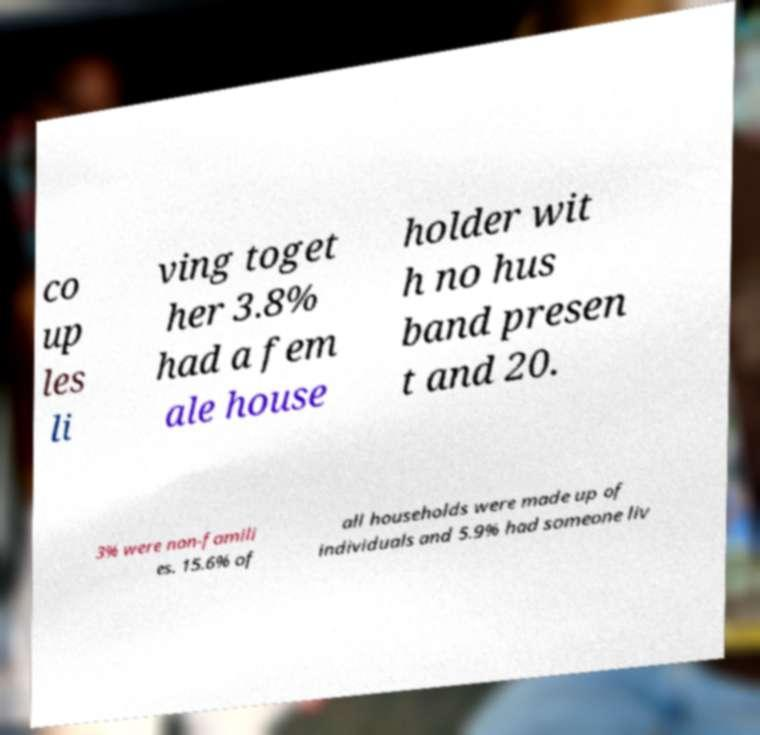Can you accurately transcribe the text from the provided image for me? co up les li ving toget her 3.8% had a fem ale house holder wit h no hus band presen t and 20. 3% were non-famili es. 15.6% of all households were made up of individuals and 5.9% had someone liv 